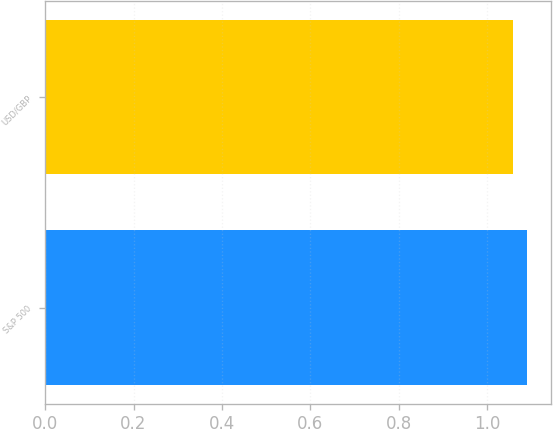<chart> <loc_0><loc_0><loc_500><loc_500><bar_chart><fcel>S&P 500<fcel>USD/GBP<nl><fcel>1.09<fcel>1.06<nl></chart> 